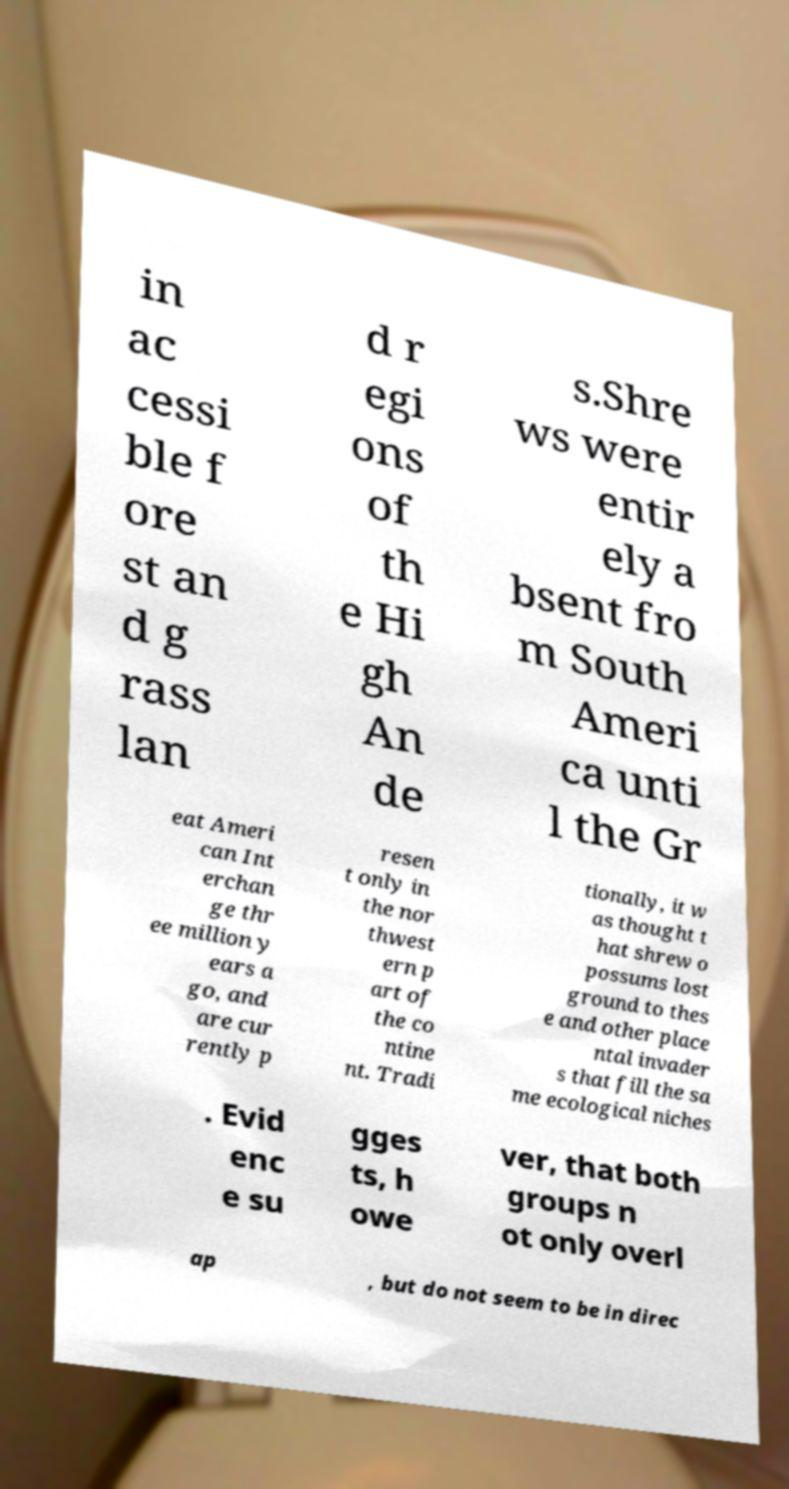I need the written content from this picture converted into text. Can you do that? in ac cessi ble f ore st an d g rass lan d r egi ons of th e Hi gh An de s.Shre ws were entir ely a bsent fro m South Ameri ca unti l the Gr eat Ameri can Int erchan ge thr ee million y ears a go, and are cur rently p resen t only in the nor thwest ern p art of the co ntine nt. Tradi tionally, it w as thought t hat shrew o possums lost ground to thes e and other place ntal invader s that fill the sa me ecological niches . Evid enc e su gges ts, h owe ver, that both groups n ot only overl ap , but do not seem to be in direc 